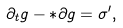<formula> <loc_0><loc_0><loc_500><loc_500>\partial _ { t } g - { * } \partial g = \sigma ^ { \prime } ,</formula> 